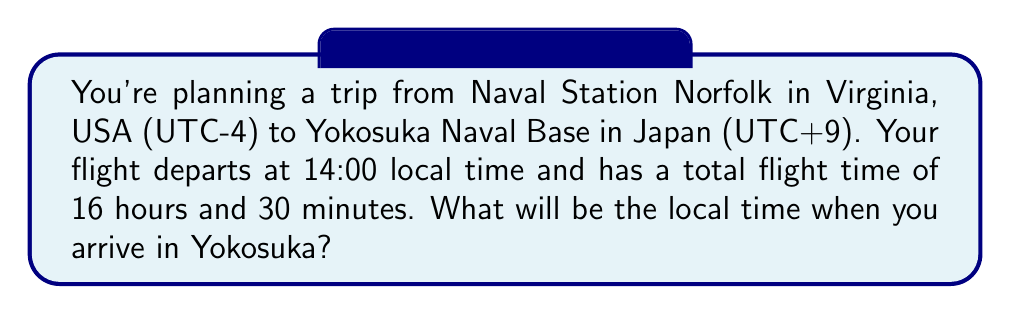Can you answer this question? Let's approach this step-by-step:

1. Identify the time difference:
   Japan is UTC+9, while Virginia is UTC-4
   Time difference = 9 - (-4) = 13 hours ahead

2. Calculate the flight duration in terms of local time:
   Flight time = 16 hours and 30 minutes
   Time zone change = 13 hours
   Total local time change = 16.5 + 13 = 29.5 hours

3. Calculate the arrival time:
   Departure time: 14:00
   Add 29.5 hours:
   14:00 + 24:00 = 14:00 (next day)
   14:00 + 5:30 = 19:30

4. Therefore, you will arrive at 19:30 local time the next day in Yokosuka.

Mathematical representation:
$$\text{Arrival Time} = (T_d + F + \Delta T) \bmod 24$$
Where:
$T_d$ = Departure time (in 24-hour format)
$F$ = Flight duration in hours
$\Delta T$ = Time zone difference

In this case:
$$\text{Arrival Time} = (14 + 16.5 + 13) \bmod 24 = 43.5 \bmod 24 = 19.5$$

Converting 19.5 to standard time gives us 19:30.
Answer: 19:30 the next day 